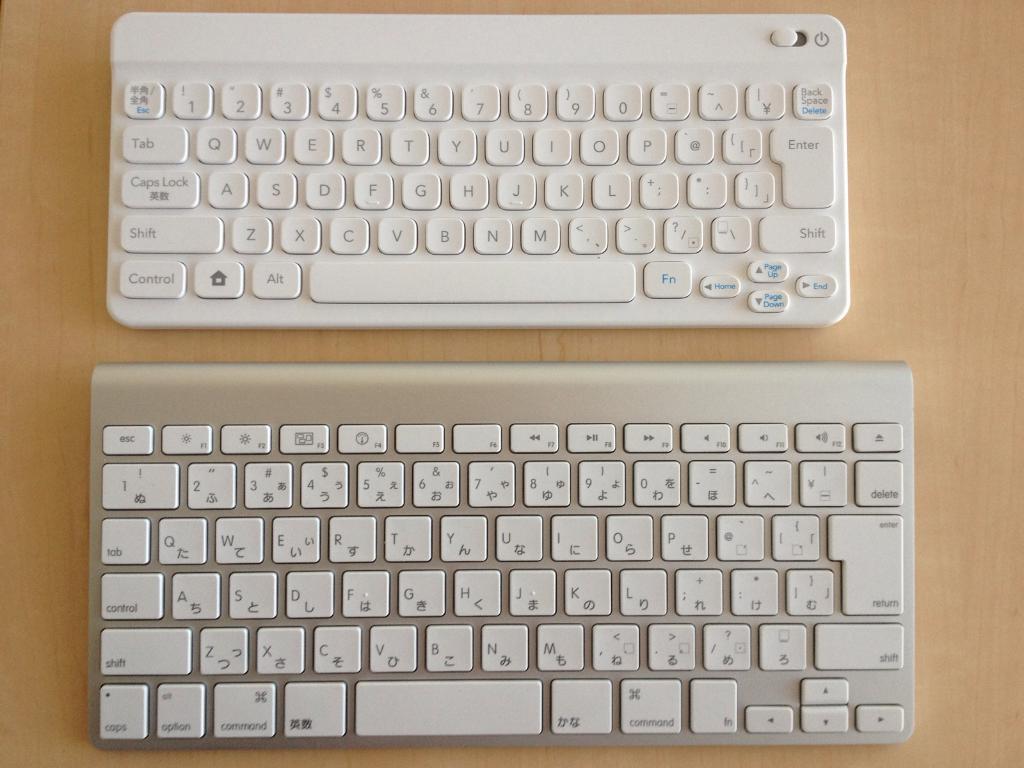In one or two sentences, can you explain what this image depicts? This image consists of keyboards which are on the brown colour surface. 